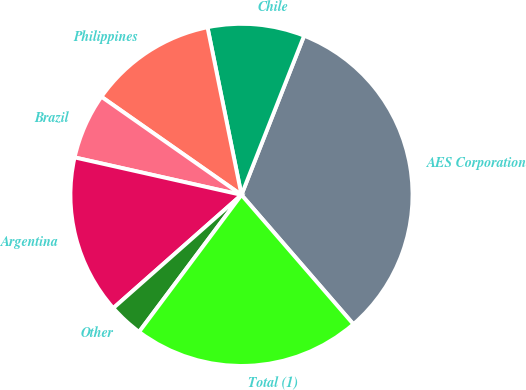<chart> <loc_0><loc_0><loc_500><loc_500><pie_chart><fcel>AES Corporation<fcel>Chile<fcel>Philippines<fcel>Brazil<fcel>Argentina<fcel>Other<fcel>Total (1)<nl><fcel>32.68%<fcel>9.15%<fcel>12.09%<fcel>6.21%<fcel>15.03%<fcel>3.27%<fcel>21.57%<nl></chart> 